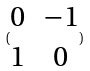Convert formula to latex. <formula><loc_0><loc_0><loc_500><loc_500>( \begin{matrix} 0 & - 1 \\ 1 & 0 \end{matrix} )</formula> 